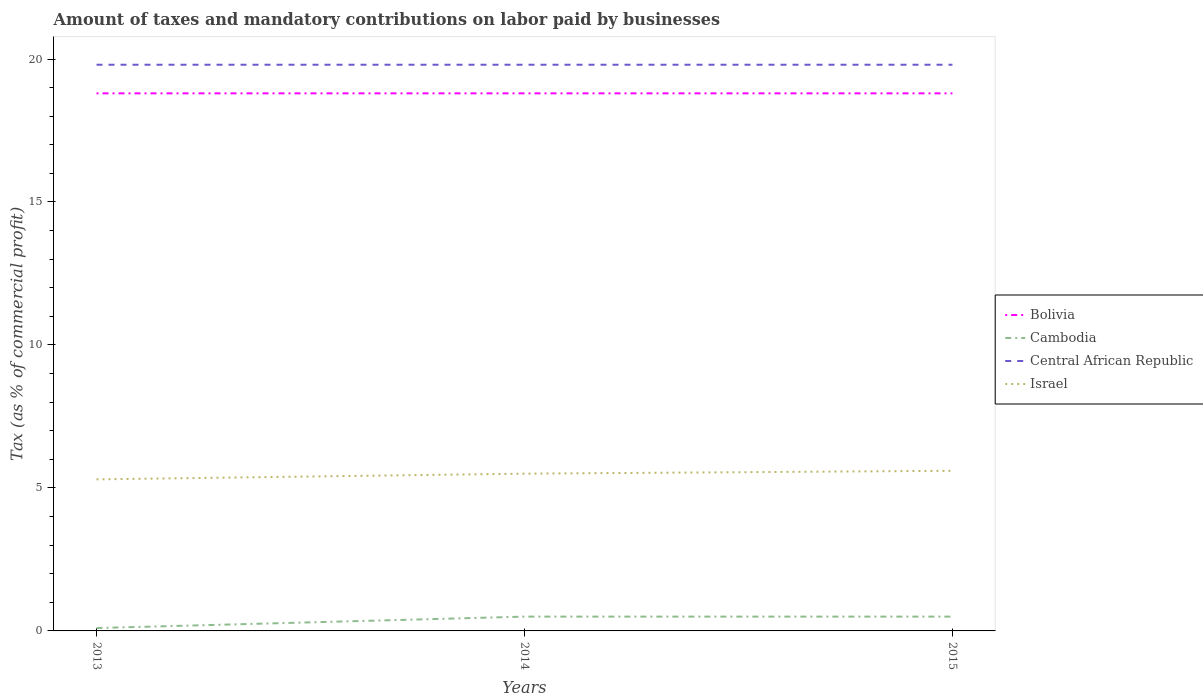Across all years, what is the maximum percentage of taxes paid by businesses in Israel?
Your response must be concise. 5.3. What is the total percentage of taxes paid by businesses in Israel in the graph?
Offer a very short reply. -0.2. What is the difference between the highest and the second highest percentage of taxes paid by businesses in Central African Republic?
Your answer should be very brief. 0. Is the percentage of taxes paid by businesses in Cambodia strictly greater than the percentage of taxes paid by businesses in Central African Republic over the years?
Give a very brief answer. Yes. How many lines are there?
Give a very brief answer. 4. What is the title of the graph?
Provide a short and direct response. Amount of taxes and mandatory contributions on labor paid by businesses. What is the label or title of the Y-axis?
Keep it short and to the point. Tax (as % of commercial profit). What is the Tax (as % of commercial profit) in Central African Republic in 2013?
Ensure brevity in your answer.  19.8. What is the Tax (as % of commercial profit) of Cambodia in 2014?
Provide a succinct answer. 0.5. What is the Tax (as % of commercial profit) in Central African Republic in 2014?
Keep it short and to the point. 19.8. What is the Tax (as % of commercial profit) in Bolivia in 2015?
Offer a terse response. 18.8. What is the Tax (as % of commercial profit) of Central African Republic in 2015?
Make the answer very short. 19.8. What is the Tax (as % of commercial profit) in Israel in 2015?
Offer a very short reply. 5.6. Across all years, what is the maximum Tax (as % of commercial profit) in Bolivia?
Offer a very short reply. 18.8. Across all years, what is the maximum Tax (as % of commercial profit) of Cambodia?
Provide a succinct answer. 0.5. Across all years, what is the maximum Tax (as % of commercial profit) of Central African Republic?
Make the answer very short. 19.8. Across all years, what is the minimum Tax (as % of commercial profit) in Central African Republic?
Your response must be concise. 19.8. What is the total Tax (as % of commercial profit) in Bolivia in the graph?
Offer a very short reply. 56.4. What is the total Tax (as % of commercial profit) of Cambodia in the graph?
Provide a succinct answer. 1.1. What is the total Tax (as % of commercial profit) in Central African Republic in the graph?
Make the answer very short. 59.4. What is the total Tax (as % of commercial profit) of Israel in the graph?
Offer a very short reply. 16.4. What is the difference between the Tax (as % of commercial profit) of Bolivia in 2013 and that in 2014?
Give a very brief answer. 0. What is the difference between the Tax (as % of commercial profit) of Central African Republic in 2013 and that in 2015?
Offer a very short reply. 0. What is the difference between the Tax (as % of commercial profit) in Israel in 2013 and that in 2015?
Your answer should be very brief. -0.3. What is the difference between the Tax (as % of commercial profit) in Central African Republic in 2014 and that in 2015?
Give a very brief answer. 0. What is the difference between the Tax (as % of commercial profit) of Bolivia in 2013 and the Tax (as % of commercial profit) of Central African Republic in 2014?
Offer a very short reply. -1. What is the difference between the Tax (as % of commercial profit) of Cambodia in 2013 and the Tax (as % of commercial profit) of Central African Republic in 2014?
Your answer should be very brief. -19.7. What is the difference between the Tax (as % of commercial profit) of Cambodia in 2013 and the Tax (as % of commercial profit) of Central African Republic in 2015?
Give a very brief answer. -19.7. What is the difference between the Tax (as % of commercial profit) in Cambodia in 2013 and the Tax (as % of commercial profit) in Israel in 2015?
Provide a short and direct response. -5.5. What is the difference between the Tax (as % of commercial profit) of Bolivia in 2014 and the Tax (as % of commercial profit) of Central African Republic in 2015?
Make the answer very short. -1. What is the difference between the Tax (as % of commercial profit) of Bolivia in 2014 and the Tax (as % of commercial profit) of Israel in 2015?
Make the answer very short. 13.2. What is the difference between the Tax (as % of commercial profit) in Cambodia in 2014 and the Tax (as % of commercial profit) in Central African Republic in 2015?
Offer a terse response. -19.3. What is the difference between the Tax (as % of commercial profit) in Cambodia in 2014 and the Tax (as % of commercial profit) in Israel in 2015?
Give a very brief answer. -5.1. What is the difference between the Tax (as % of commercial profit) of Central African Republic in 2014 and the Tax (as % of commercial profit) of Israel in 2015?
Offer a very short reply. 14.2. What is the average Tax (as % of commercial profit) in Cambodia per year?
Ensure brevity in your answer.  0.37. What is the average Tax (as % of commercial profit) of Central African Republic per year?
Ensure brevity in your answer.  19.8. What is the average Tax (as % of commercial profit) of Israel per year?
Offer a very short reply. 5.47. In the year 2013, what is the difference between the Tax (as % of commercial profit) of Bolivia and Tax (as % of commercial profit) of Cambodia?
Your answer should be compact. 18.7. In the year 2013, what is the difference between the Tax (as % of commercial profit) of Bolivia and Tax (as % of commercial profit) of Central African Republic?
Offer a very short reply. -1. In the year 2013, what is the difference between the Tax (as % of commercial profit) in Bolivia and Tax (as % of commercial profit) in Israel?
Keep it short and to the point. 13.5. In the year 2013, what is the difference between the Tax (as % of commercial profit) in Cambodia and Tax (as % of commercial profit) in Central African Republic?
Give a very brief answer. -19.7. In the year 2013, what is the difference between the Tax (as % of commercial profit) of Cambodia and Tax (as % of commercial profit) of Israel?
Your response must be concise. -5.2. In the year 2014, what is the difference between the Tax (as % of commercial profit) in Bolivia and Tax (as % of commercial profit) in Cambodia?
Provide a short and direct response. 18.3. In the year 2014, what is the difference between the Tax (as % of commercial profit) of Bolivia and Tax (as % of commercial profit) of Israel?
Provide a short and direct response. 13.3. In the year 2014, what is the difference between the Tax (as % of commercial profit) in Cambodia and Tax (as % of commercial profit) in Central African Republic?
Your answer should be very brief. -19.3. In the year 2014, what is the difference between the Tax (as % of commercial profit) in Cambodia and Tax (as % of commercial profit) in Israel?
Your answer should be very brief. -5. In the year 2014, what is the difference between the Tax (as % of commercial profit) in Central African Republic and Tax (as % of commercial profit) in Israel?
Your answer should be compact. 14.3. In the year 2015, what is the difference between the Tax (as % of commercial profit) in Cambodia and Tax (as % of commercial profit) in Central African Republic?
Your response must be concise. -19.3. In the year 2015, what is the difference between the Tax (as % of commercial profit) of Cambodia and Tax (as % of commercial profit) of Israel?
Your answer should be very brief. -5.1. In the year 2015, what is the difference between the Tax (as % of commercial profit) in Central African Republic and Tax (as % of commercial profit) in Israel?
Your answer should be compact. 14.2. What is the ratio of the Tax (as % of commercial profit) of Bolivia in 2013 to that in 2014?
Provide a short and direct response. 1. What is the ratio of the Tax (as % of commercial profit) in Cambodia in 2013 to that in 2014?
Provide a succinct answer. 0.2. What is the ratio of the Tax (as % of commercial profit) in Israel in 2013 to that in 2014?
Your answer should be compact. 0.96. What is the ratio of the Tax (as % of commercial profit) of Cambodia in 2013 to that in 2015?
Provide a short and direct response. 0.2. What is the ratio of the Tax (as % of commercial profit) of Central African Republic in 2013 to that in 2015?
Offer a terse response. 1. What is the ratio of the Tax (as % of commercial profit) in Israel in 2013 to that in 2015?
Ensure brevity in your answer.  0.95. What is the ratio of the Tax (as % of commercial profit) in Cambodia in 2014 to that in 2015?
Provide a short and direct response. 1. What is the ratio of the Tax (as % of commercial profit) of Central African Republic in 2014 to that in 2015?
Provide a short and direct response. 1. What is the ratio of the Tax (as % of commercial profit) of Israel in 2014 to that in 2015?
Ensure brevity in your answer.  0.98. What is the difference between the highest and the second highest Tax (as % of commercial profit) in Central African Republic?
Make the answer very short. 0. What is the difference between the highest and the lowest Tax (as % of commercial profit) in Bolivia?
Offer a very short reply. 0. What is the difference between the highest and the lowest Tax (as % of commercial profit) in Central African Republic?
Offer a very short reply. 0. What is the difference between the highest and the lowest Tax (as % of commercial profit) in Israel?
Make the answer very short. 0.3. 